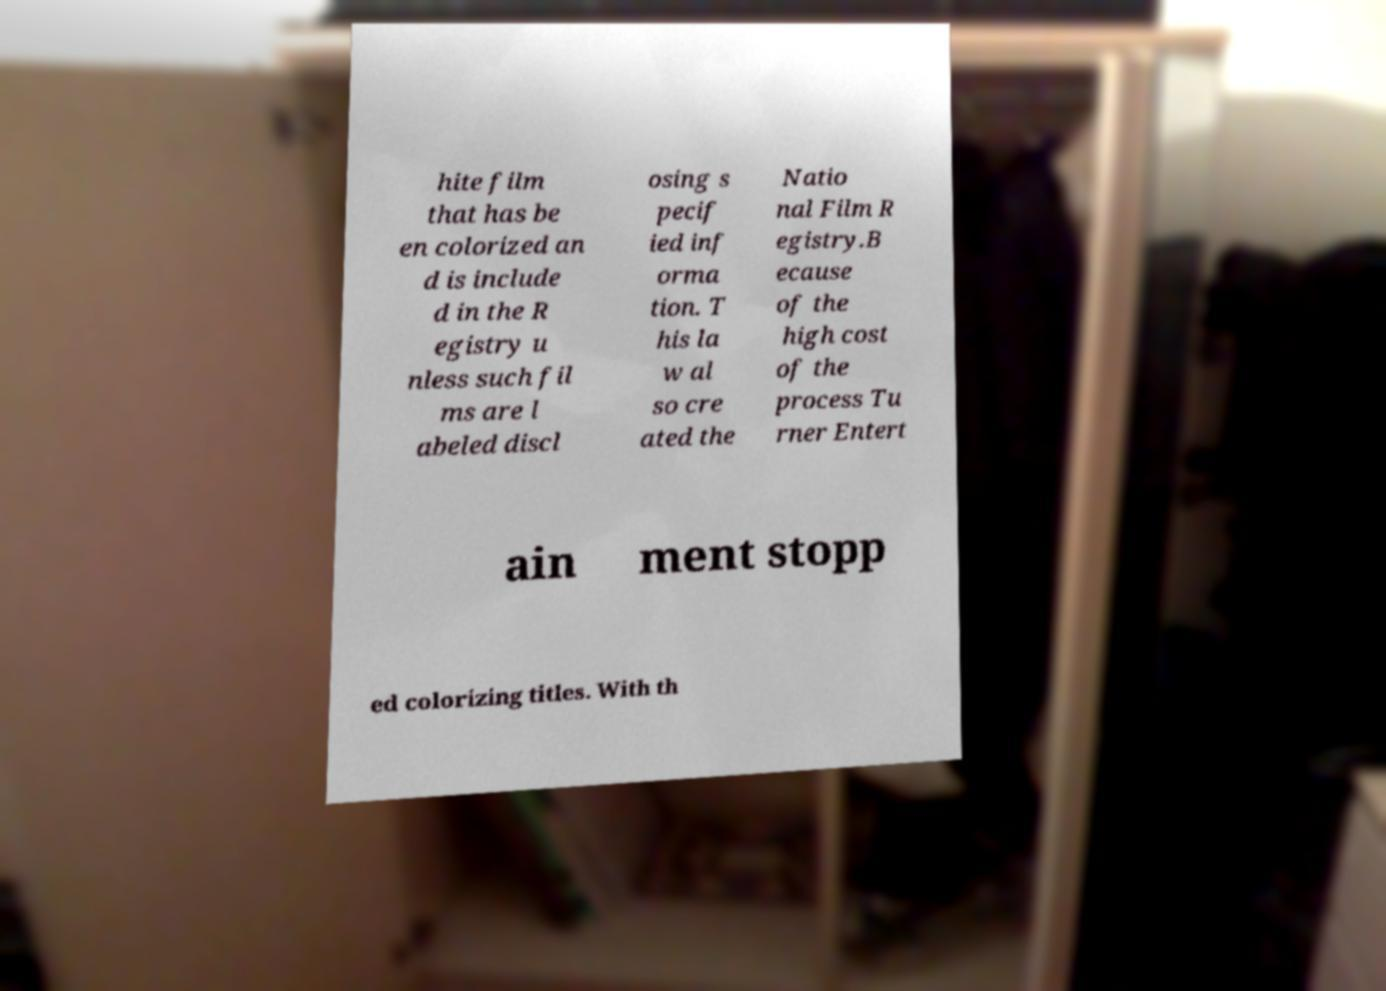What messages or text are displayed in this image? I need them in a readable, typed format. hite film that has be en colorized an d is include d in the R egistry u nless such fil ms are l abeled discl osing s pecif ied inf orma tion. T his la w al so cre ated the Natio nal Film R egistry.B ecause of the high cost of the process Tu rner Entert ain ment stopp ed colorizing titles. With th 